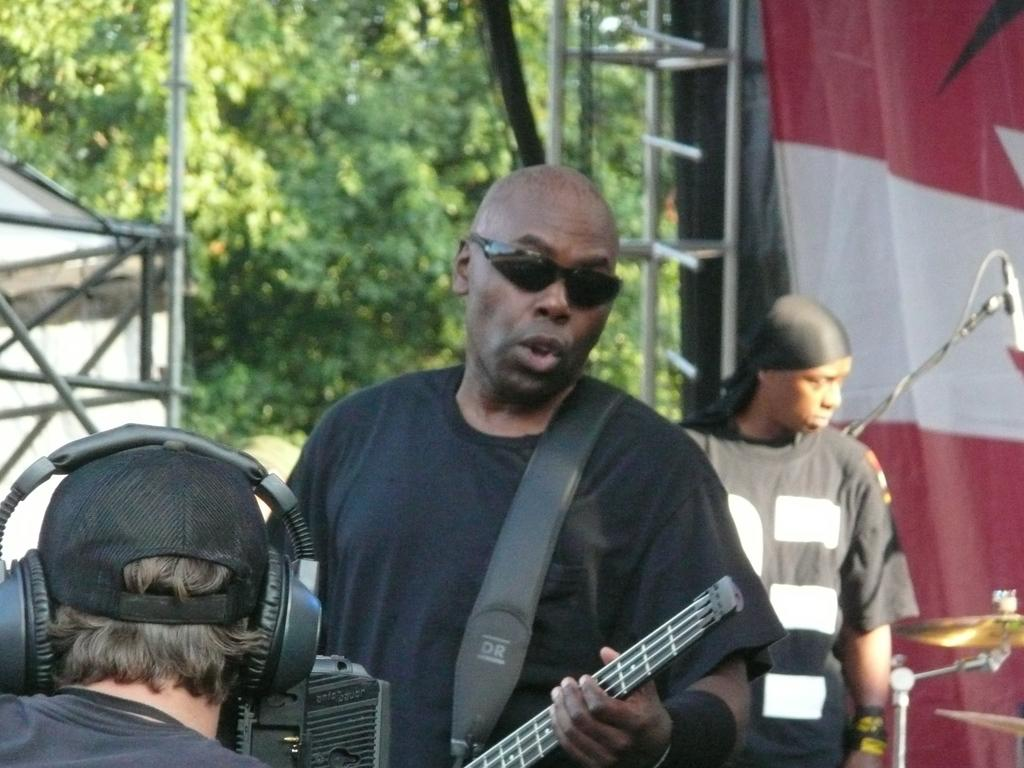How many people are in the image? There are three persons in the image. What is the person on the left side of the image wearing? One person is wearing goggles. What is the person with goggles doing? The person with goggles is playing a guitar. What can be seen in the background of the image? There are trees in the background of the image. Can you describe the cloth visible in the image? Yes, there is a cloth visible in the image. What type of game is being played with the box and vase in the image? There is no box or vase present in the image, and therefore no such game can be observed. 